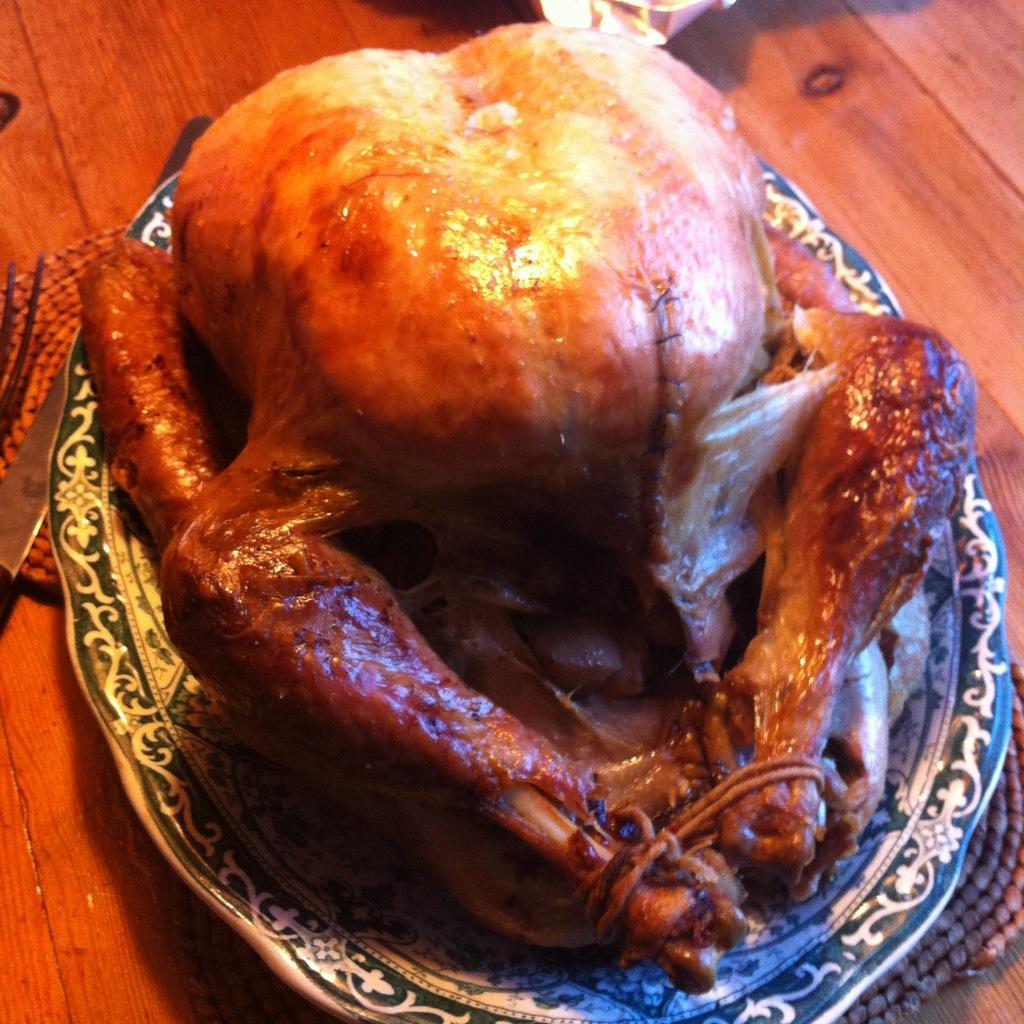Please provide a concise description of this image. In this image I can see roasted chicken on a plate. The plate is placed on a table. Beside the plate there is a knife. 